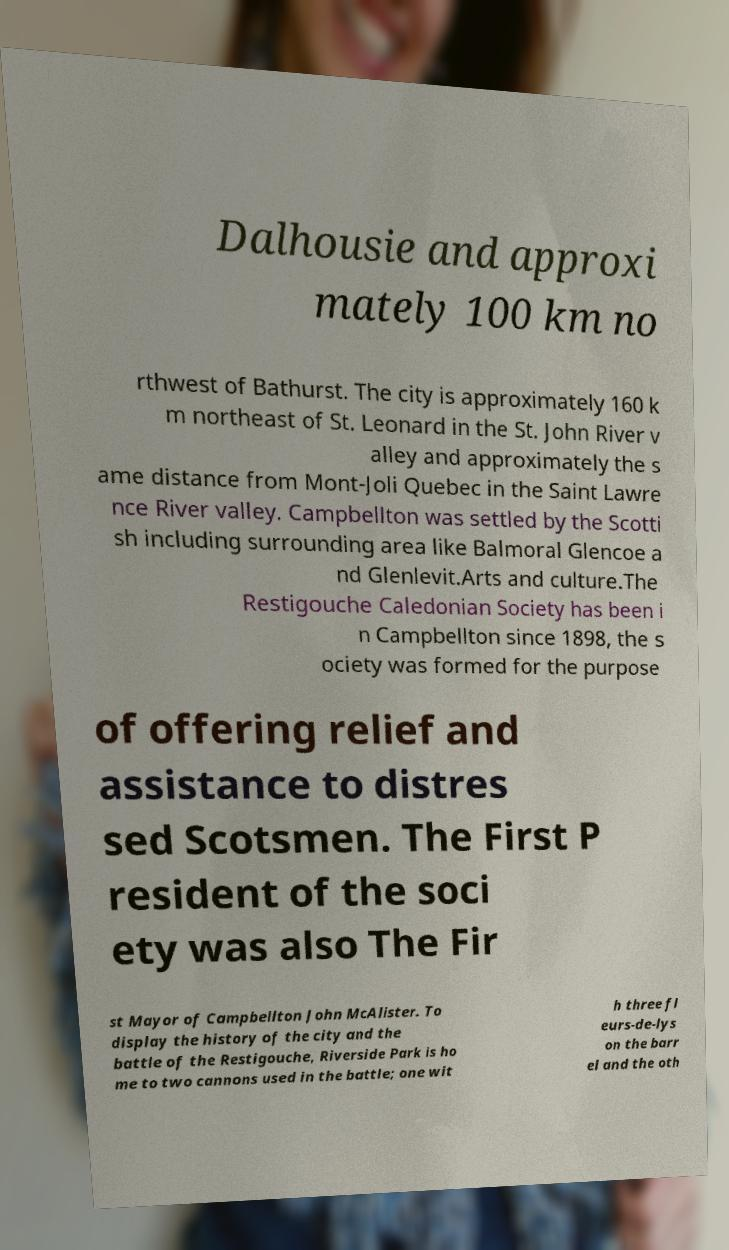I need the written content from this picture converted into text. Can you do that? Dalhousie and approxi mately 100 km no rthwest of Bathurst. The city is approximately 160 k m northeast of St. Leonard in the St. John River v alley and approximately the s ame distance from Mont-Joli Quebec in the Saint Lawre nce River valley. Campbellton was settled by the Scotti sh including surrounding area like Balmoral Glencoe a nd Glenlevit.Arts and culture.The Restigouche Caledonian Society has been i n Campbellton since 1898, the s ociety was formed for the purpose of offering relief and assistance to distres sed Scotsmen. The First P resident of the soci ety was also The Fir st Mayor of Campbellton John McAlister. To display the history of the city and the battle of the Restigouche, Riverside Park is ho me to two cannons used in the battle; one wit h three fl eurs-de-lys on the barr el and the oth 